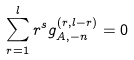Convert formula to latex. <formula><loc_0><loc_0><loc_500><loc_500>\sum _ { r = 1 } ^ { l } r ^ { s } g ^ { ( r , l - r ) } _ { A , - n } = 0</formula> 